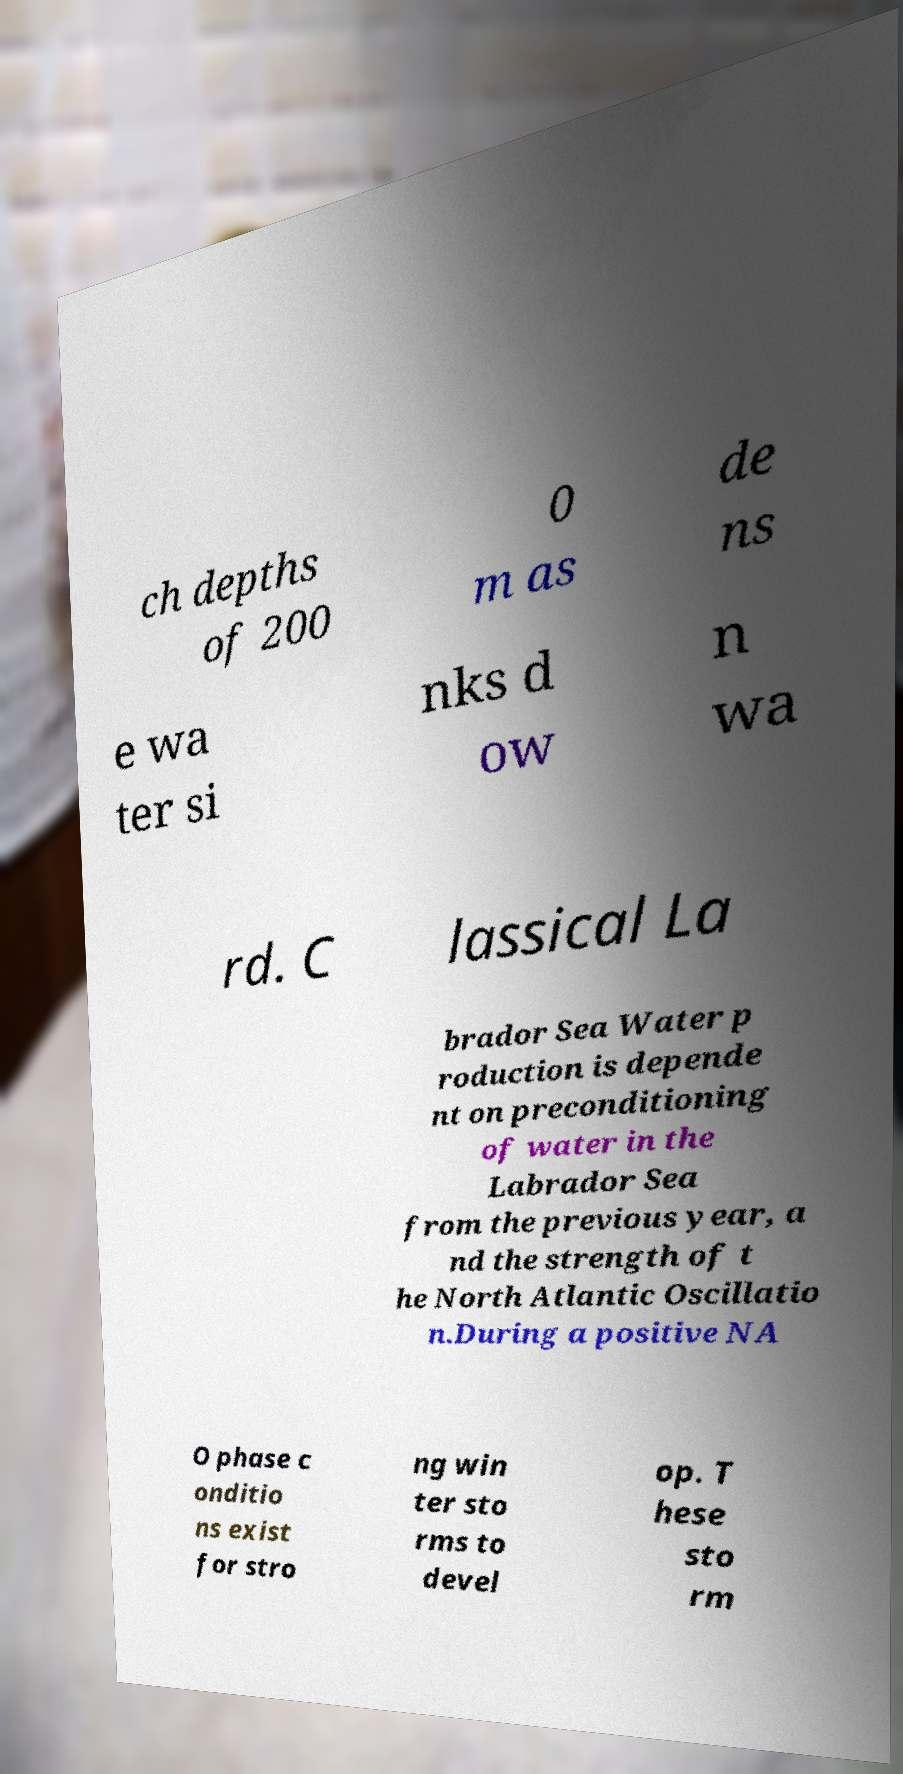Please read and relay the text visible in this image. What does it say? ch depths of 200 0 m as de ns e wa ter si nks d ow n wa rd. C lassical La brador Sea Water p roduction is depende nt on preconditioning of water in the Labrador Sea from the previous year, a nd the strength of t he North Atlantic Oscillatio n.During a positive NA O phase c onditio ns exist for stro ng win ter sto rms to devel op. T hese sto rm 